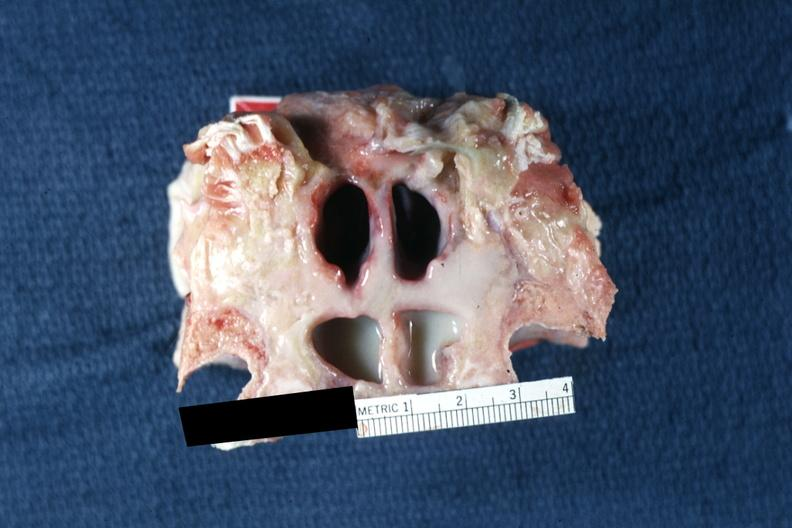what well shown?
Answer the question using a single word or phrase. Frontal sinuses inflammation and pus 